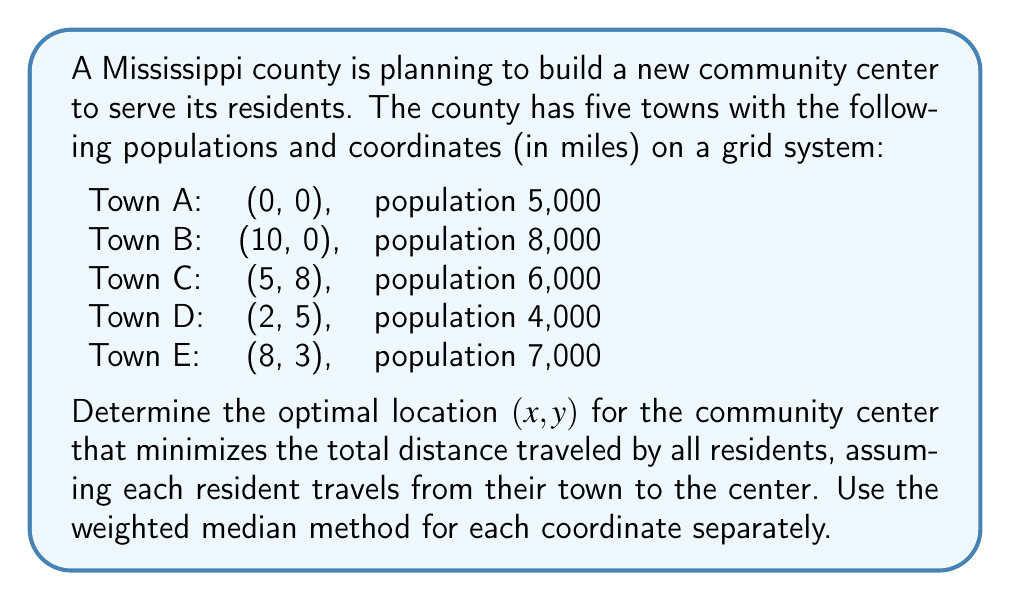What is the answer to this math problem? To solve this problem, we'll use the weighted median method for each coordinate (x and y) separately. This method is appropriate when minimizing the sum of absolute distances.

1. For the x-coordinate:
   Sort the x-coordinates with their corresponding populations:
   (0, 5000), (2, 4000), (5, 6000), (8, 7000), (10, 8000)

   Total population: 30,000
   We need to find the point where the cumulative population reaches or exceeds 15,000 (half of the total).

   Cumulative populations:
   0: 5,000
   2: 9,000
   5: 15,000 (reaches half of total)

   Therefore, the optimal x-coordinate is 5.

2. For the y-coordinate:
   Sort the y-coordinates with their corresponding populations:
   (0, 13000), (3, 7000), (5, 4000), (8, 6000)

   Total population: 30,000
   We need to find the point where the cumulative population reaches or exceeds 15,000.

   Cumulative populations:
   0: 13,000
   3: 20,000 (exceeds half of total)

   Therefore, the optimal y-coordinate is 3.

The optimal location for the community center is (5, 3).

To verify this is indeed the optimal solution, we can calculate the total weighted distance for this point:

$$\begin{align*}
\text{Total Distance} &= 5000\sqrt{5^2 + 3^2} + 8000\sqrt{5^2 + 3^2} + 6000\sqrt{0^2 + 5^2} \\
&\quad + 4000\sqrt{3^2 + 2^2} + 7000\sqrt{3^2 + 0^2} \\
&\approx 185,771 \text{ person-miles}
\end{align*}$$

This is the minimum total distance that can be achieved for any location.
Answer: The optimal location for the new community center is (5, 3) miles on the grid system. 